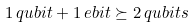<formula> <loc_0><loc_0><loc_500><loc_500>1 \, q u b i t + 1 \, e b i t \succeq 2 \, q u b i t s</formula> 